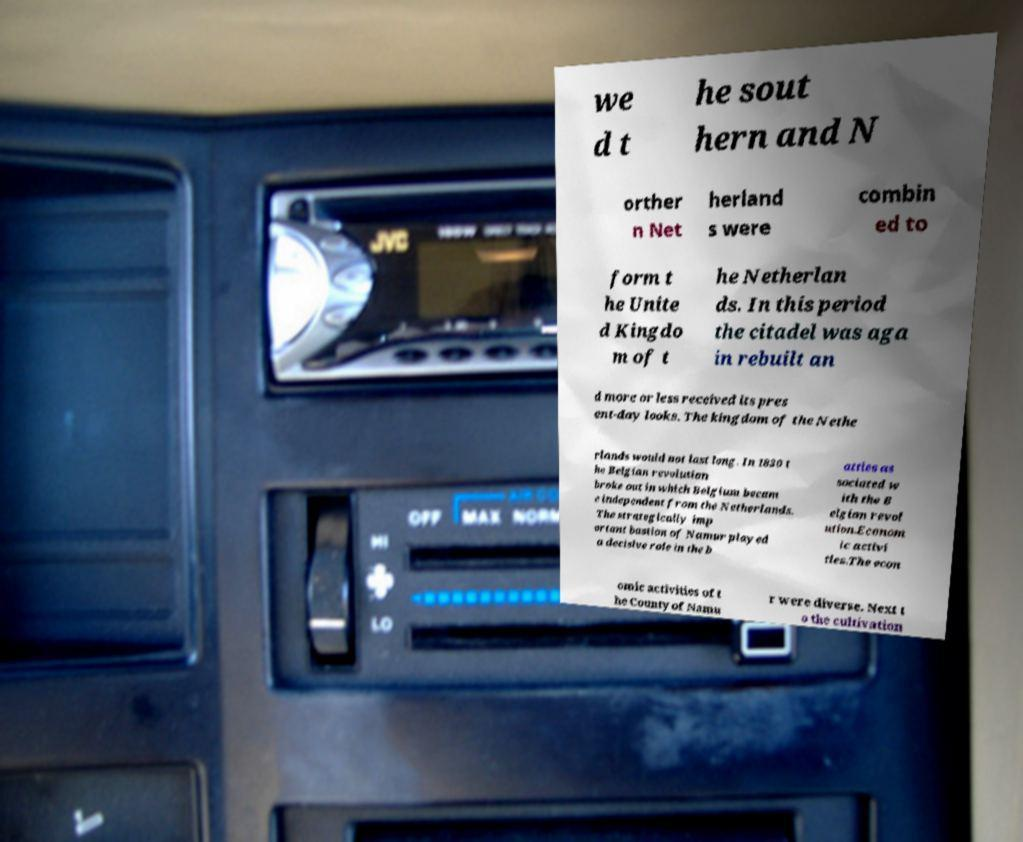Could you extract and type out the text from this image? we d t he sout hern and N orther n Net herland s were combin ed to form t he Unite d Kingdo m of t he Netherlan ds. In this period the citadel was aga in rebuilt an d more or less received its pres ent-day looks. The kingdom of the Nethe rlands would not last long. In 1830 t he Belgian revolution broke out in which Belgium becam e independent from the Netherlands. The strategically imp ortant bastion of Namur played a decisive role in the b attles as sociated w ith the B elgian revol ution.Econom ic activi ties.The econ omic activities of t he County of Namu r were diverse. Next t o the cultivation 